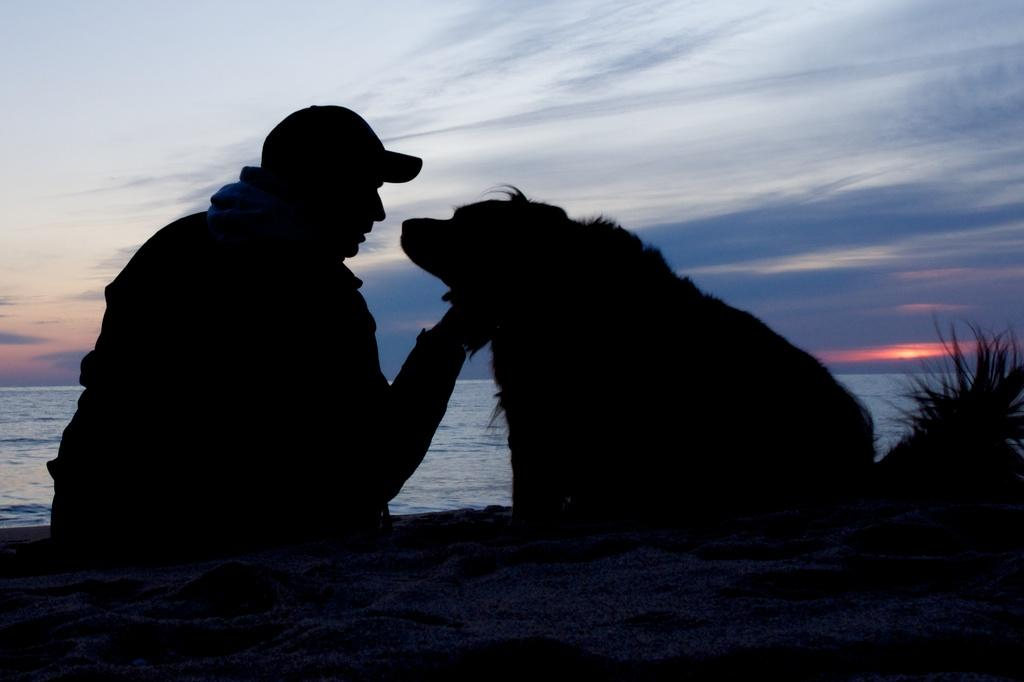What is the lighting condition of the front of the image? The front of the image is dark. Can you describe the person in the image? There is a person in the image. What activity is the person engaged in? The person is digging in the image. What type of terrain is present in the image? There is sand in the image. What type of vegetation is present in the image? There is a plant in the image. What can be seen in the background of the image? There is water visible in the background of the image. How would you describe the weather in the image? The sky is cloudy in the image. What is the name of the queen who is present in the image? There is no queen present in the image. What type of paste is being used by the person in the image? There is no paste visible or mentioned in the image. 